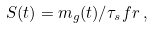Convert formula to latex. <formula><loc_0><loc_0><loc_500><loc_500>S ( t ) = m _ { g } ( t ) / \tau _ { s } f r \, ,</formula> 